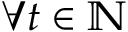Convert formula to latex. <formula><loc_0><loc_0><loc_500><loc_500>\forall t \in \mathbb { N }</formula> 